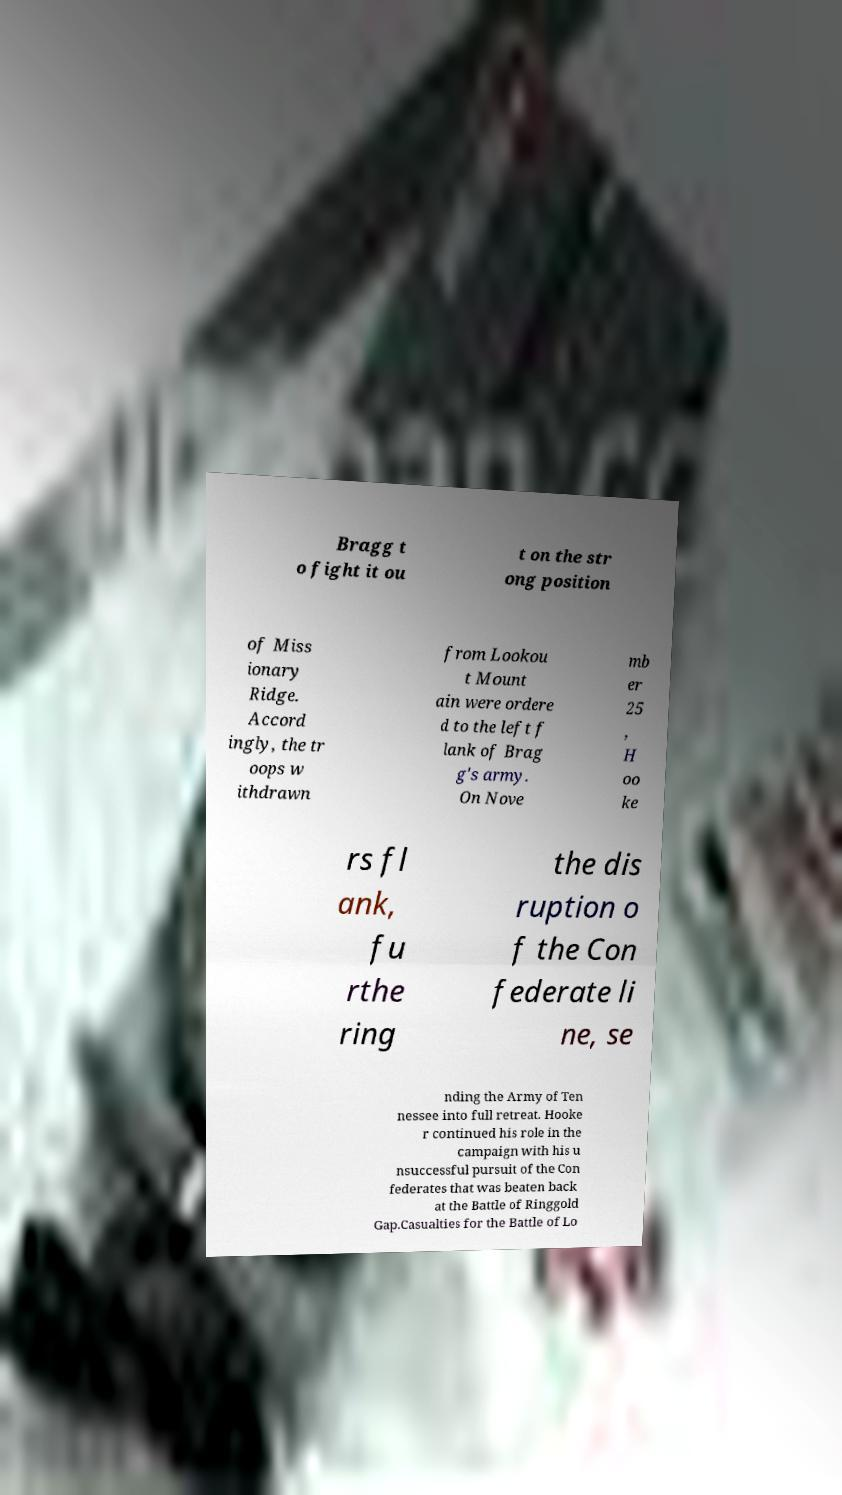There's text embedded in this image that I need extracted. Can you transcribe it verbatim? Bragg t o fight it ou t on the str ong position of Miss ionary Ridge. Accord ingly, the tr oops w ithdrawn from Lookou t Mount ain were ordere d to the left f lank of Brag g's army. On Nove mb er 25 , H oo ke rs fl ank, fu rthe ring the dis ruption o f the Con federate li ne, se nding the Army of Ten nessee into full retreat. Hooke r continued his role in the campaign with his u nsuccessful pursuit of the Con federates that was beaten back at the Battle of Ringgold Gap.Casualties for the Battle of Lo 